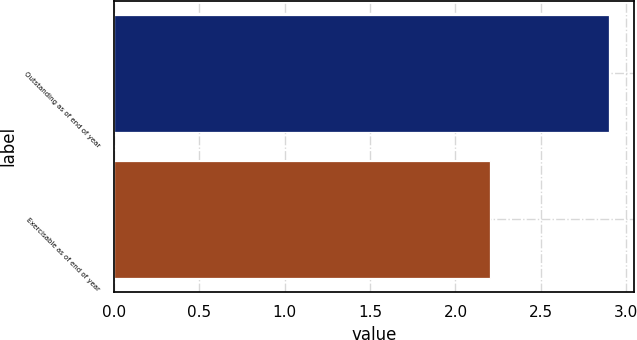Convert chart to OTSL. <chart><loc_0><loc_0><loc_500><loc_500><bar_chart><fcel>Outstanding as of end of year<fcel>Exercisable as of end of year<nl><fcel>2.9<fcel>2.2<nl></chart> 